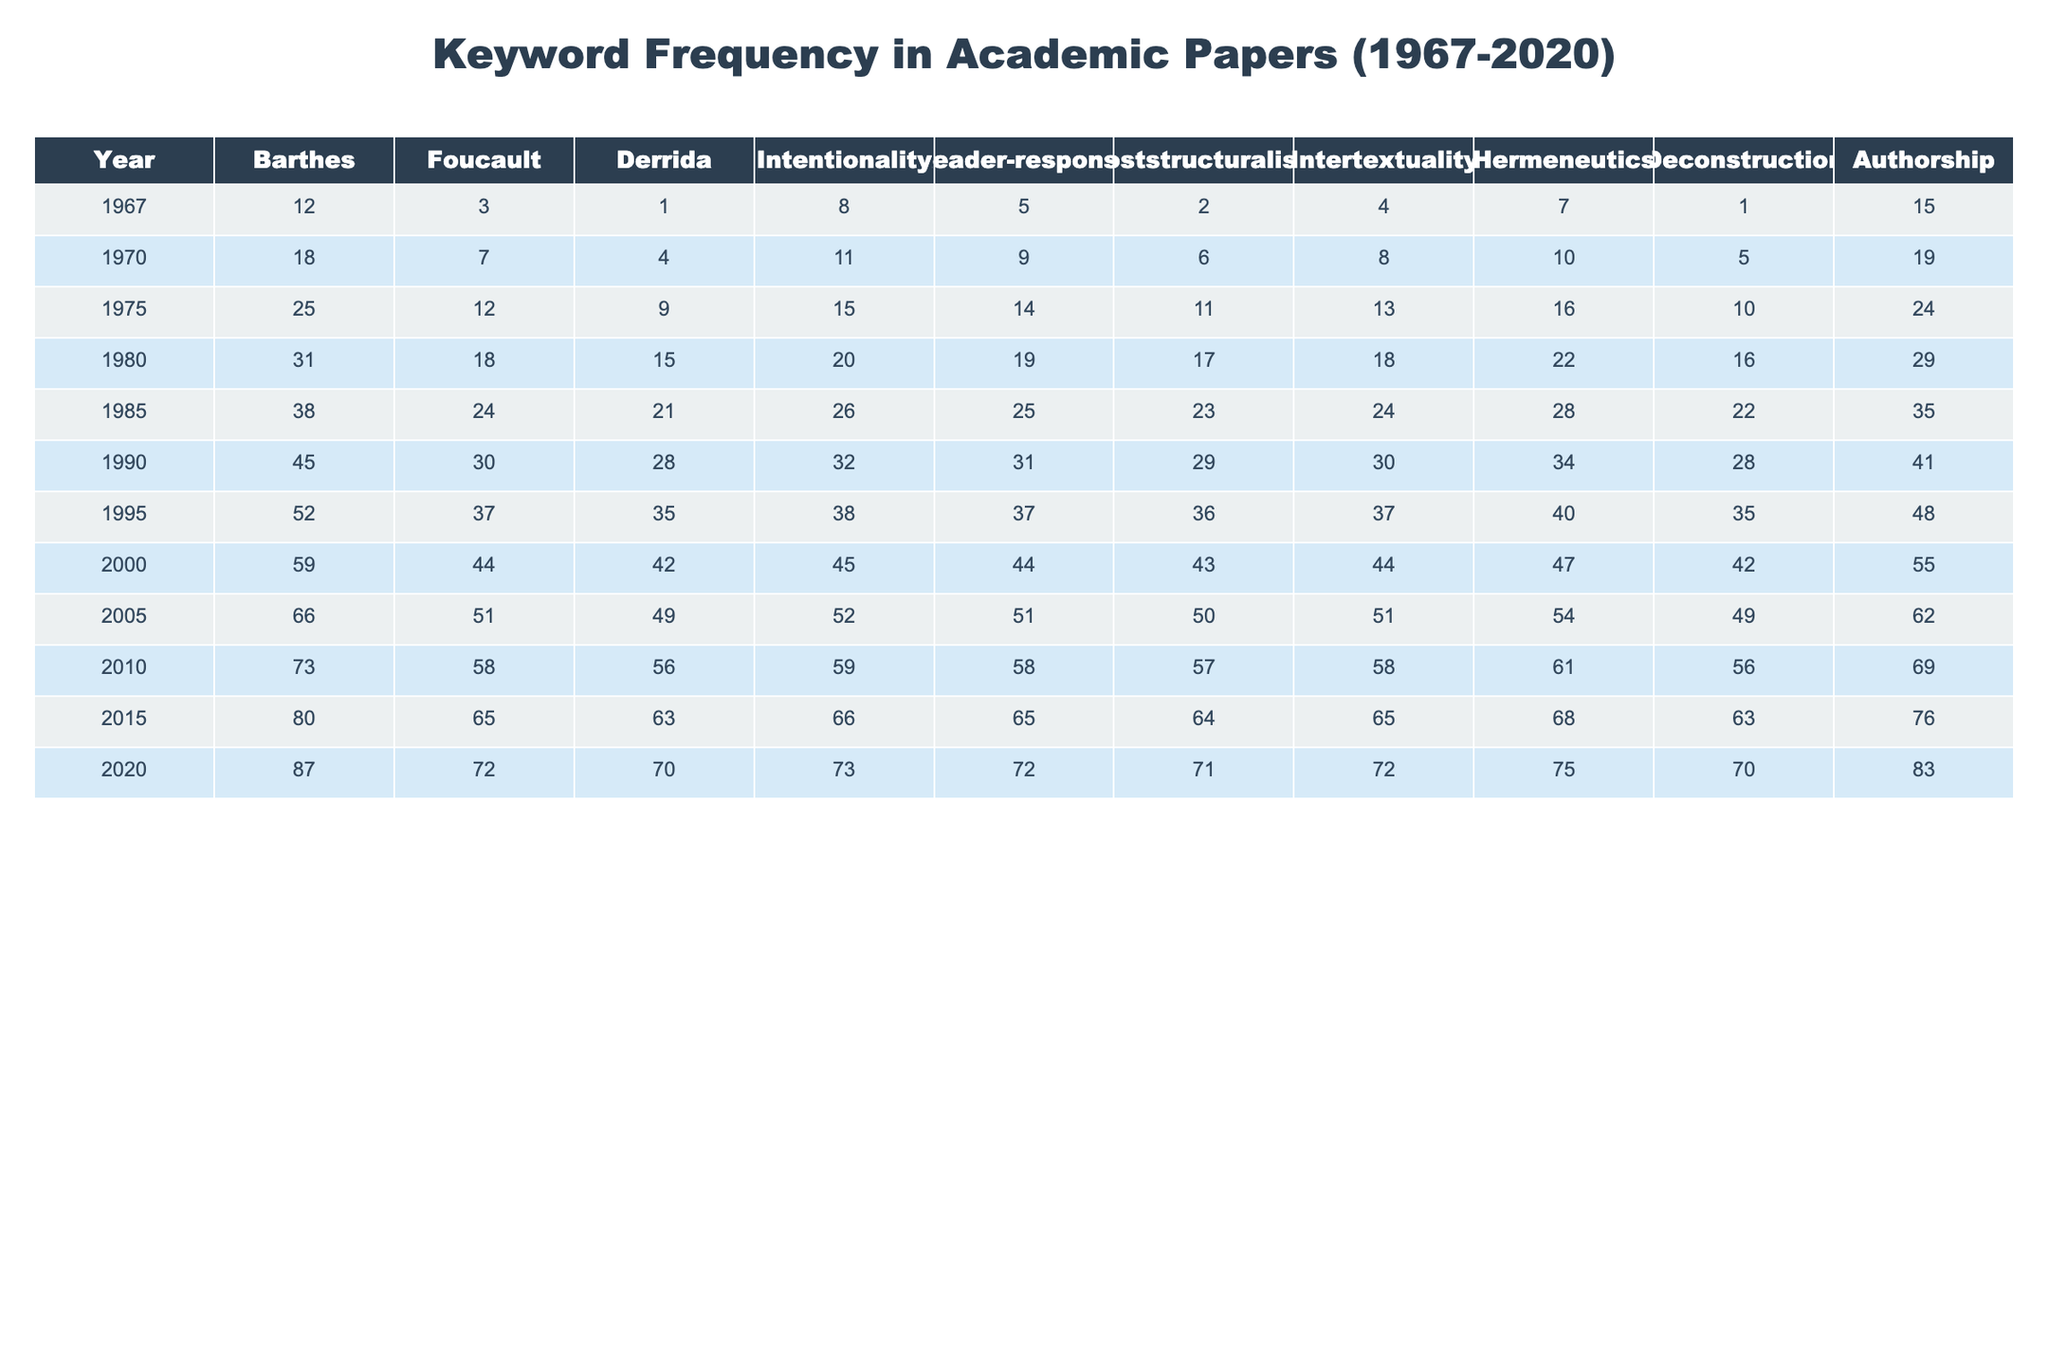What is the keyword with the highest frequency in 1985? In the row for 1985, the frequency counts show 'Foucault' has the highest value of 24. Therefore, 'Foucault' is the keyword with the highest frequency that year.
Answer: Foucault Which year saw the highest frequency of the keyword 'Deconstruction'? Looking at the column for 'Deconstruction', the highest frequency appears in 2010 with a count of 56. Thus, that is the year with the highest frequency for this keyword.
Answer: 2010 What is the total frequency of the keyword 'Authorship' from 1967 to 2020? Adding up the frequencies from the 'Authorship' column for all years: 15 + 19 + 24 + 29 + 35 + 41 + 48 + 55 + 62 + 69 + 76 + 83 gives a total of 570.
Answer: 570 Which keyword had the lowest frequency in 1995? The frequencies for 1995 are: Barthes (52), Foucault (37), Derrida (35), Intentionality (38), Reader-response (37), Poststructuralism (36), Intertextuality (37), Hermeneutics (40), Deconstruction (35), Authorship (48). Here, 'Derrida' has the lowest frequency of 35.
Answer: Derrida What is the average frequency of 'Poststructuralism' across all years? To find the average for 'Poststructuralism', we sum the frequencies: 2 + 6 + 11 + 17 + 23 + 29 + 36 + 43 + 50 + 57 + 64 + 71, which equals 410. Then divide by the number of years (12): 410 / 12 = 34.17.
Answer: 34.17 In 2020, did the frequency of 'Intentionality' exceed that of 'Hermeneutics'? In 2020, the frequency of 'Intentionality' is 73, while 'Hermeneutics' is 75. Since 73 is less than 75, the frequency of 'Intentionality' did not exceed 'Hermeneutics'.
Answer: No Which keyword has the most consistent growth in frequency from 1967 to 2020? By examining the annual changes for all keywords, 'Authorship' increases steadily from 15 to 83. Other keywords fluctuate more significantly. Therefore, 'Authorship' demonstrates the most consistent growth.
Answer: Authorship What was the difference in frequency of 'Barthes' between 1975 and 2015? The frequency of 'Barthes' in 1975 is 25 and in 2015 is 80. The difference is calculated by 80 - 25 = 55.
Answer: 55 How many keywords had a frequency of 0 at any year? Reviewing all frequency counts from the table, no keyword shows a frequency of 0 in any year. Therefore, the answer is zero.
Answer: No What is the maximum frequency of 'Reader-response' in any single year? The column for 'Reader-response' shows frequencies of 5, 9, 14, 19, 25, 31, 37, 44, 51, 58, 65, 72 over the years, with the maximum being 72 in 2020.
Answer: 72 